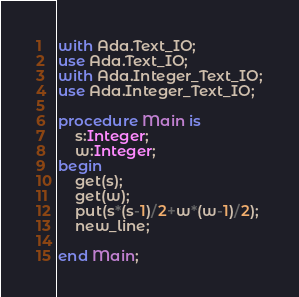<code> <loc_0><loc_0><loc_500><loc_500><_Ada_>with Ada.Text_IO;
use Ada.Text_IO;
with Ada.Integer_Text_IO;
use Ada.Integer_Text_IO;

procedure Main is
	s:Integer;
    w:Integer;
begin
	get(s);
	get(w);
    put(s*(s-1)/2+w*(w-1)/2);
	new_line;
    
end Main;</code> 